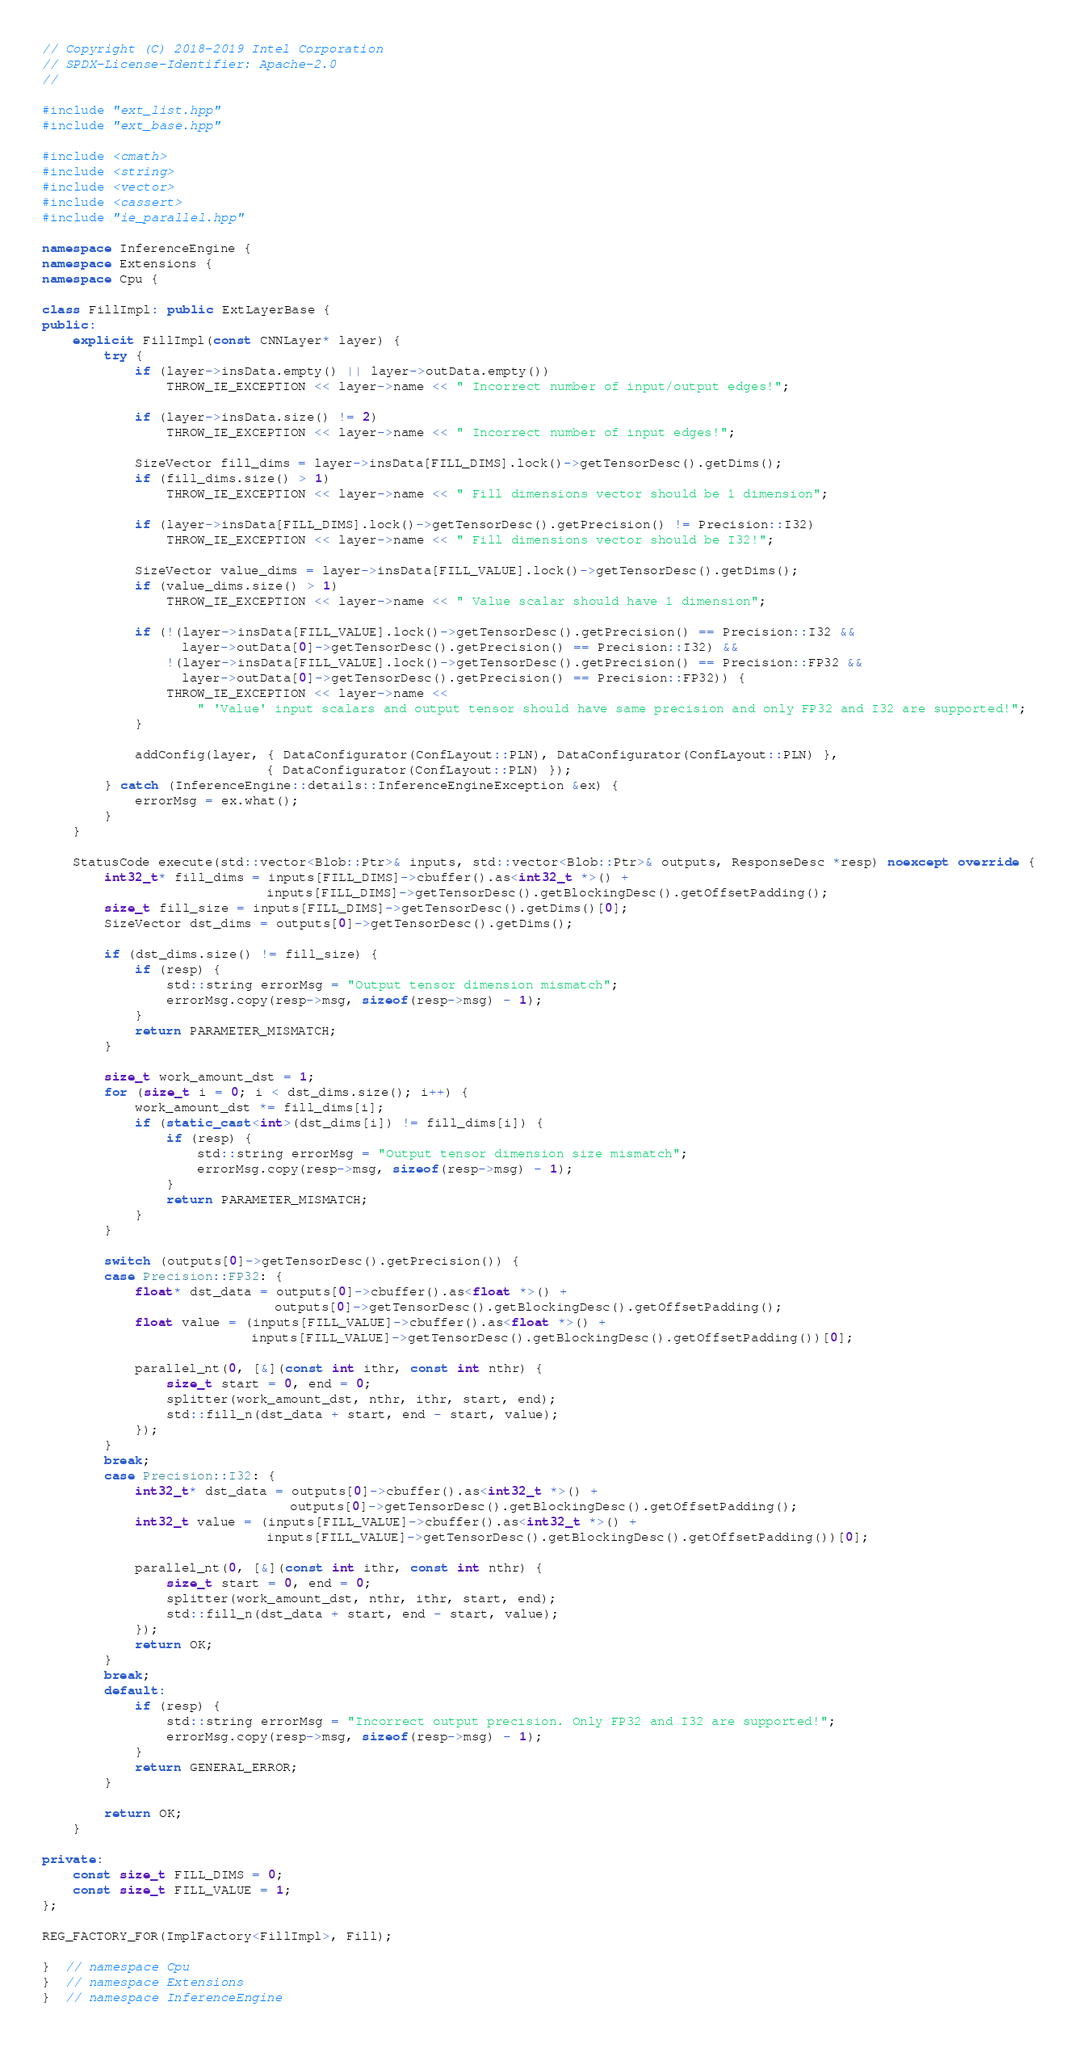Convert code to text. <code><loc_0><loc_0><loc_500><loc_500><_C++_>// Copyright (C) 2018-2019 Intel Corporation
// SPDX-License-Identifier: Apache-2.0
//

#include "ext_list.hpp"
#include "ext_base.hpp"

#include <cmath>
#include <string>
#include <vector>
#include <cassert>
#include "ie_parallel.hpp"

namespace InferenceEngine {
namespace Extensions {
namespace Cpu {

class FillImpl: public ExtLayerBase {
public:
    explicit FillImpl(const CNNLayer* layer) {
        try {
            if (layer->insData.empty() || layer->outData.empty())
                THROW_IE_EXCEPTION << layer->name << " Incorrect number of input/output edges!";

            if (layer->insData.size() != 2)
                THROW_IE_EXCEPTION << layer->name << " Incorrect number of input edges!";

            SizeVector fill_dims = layer->insData[FILL_DIMS].lock()->getTensorDesc().getDims();
            if (fill_dims.size() > 1)
                THROW_IE_EXCEPTION << layer->name << " Fill dimensions vector should be 1 dimension";

            if (layer->insData[FILL_DIMS].lock()->getTensorDesc().getPrecision() != Precision::I32)
                THROW_IE_EXCEPTION << layer->name << " Fill dimensions vector should be I32!";

            SizeVector value_dims = layer->insData[FILL_VALUE].lock()->getTensorDesc().getDims();
            if (value_dims.size() > 1)
                THROW_IE_EXCEPTION << layer->name << " Value scalar should have 1 dimension";

            if (!(layer->insData[FILL_VALUE].lock()->getTensorDesc().getPrecision() == Precision::I32 &&
                  layer->outData[0]->getTensorDesc().getPrecision() == Precision::I32) &&
                !(layer->insData[FILL_VALUE].lock()->getTensorDesc().getPrecision() == Precision::FP32 &&
                  layer->outData[0]->getTensorDesc().getPrecision() == Precision::FP32)) {
                THROW_IE_EXCEPTION << layer->name <<
                    " 'Value' input scalars and output tensor should have same precision and only FP32 and I32 are supported!";
            }

            addConfig(layer, { DataConfigurator(ConfLayout::PLN), DataConfigurator(ConfLayout::PLN) },
                             { DataConfigurator(ConfLayout::PLN) });
        } catch (InferenceEngine::details::InferenceEngineException &ex) {
            errorMsg = ex.what();
        }
    }

    StatusCode execute(std::vector<Blob::Ptr>& inputs, std::vector<Blob::Ptr>& outputs, ResponseDesc *resp) noexcept override {
        int32_t* fill_dims = inputs[FILL_DIMS]->cbuffer().as<int32_t *>() +
                             inputs[FILL_DIMS]->getTensorDesc().getBlockingDesc().getOffsetPadding();
        size_t fill_size = inputs[FILL_DIMS]->getTensorDesc().getDims()[0];
        SizeVector dst_dims = outputs[0]->getTensorDesc().getDims();

        if (dst_dims.size() != fill_size) {
            if (resp) {
                std::string errorMsg = "Output tensor dimension mismatch";
                errorMsg.copy(resp->msg, sizeof(resp->msg) - 1);
            }
            return PARAMETER_MISMATCH;
        }

        size_t work_amount_dst = 1;
        for (size_t i = 0; i < dst_dims.size(); i++) {
            work_amount_dst *= fill_dims[i];
            if (static_cast<int>(dst_dims[i]) != fill_dims[i]) {
                if (resp) {
                    std::string errorMsg = "Output tensor dimension size mismatch";
                    errorMsg.copy(resp->msg, sizeof(resp->msg) - 1);
                }
                return PARAMETER_MISMATCH;
            }
        }

        switch (outputs[0]->getTensorDesc().getPrecision()) {
        case Precision::FP32: {
            float* dst_data = outputs[0]->cbuffer().as<float *>() +
                              outputs[0]->getTensorDesc().getBlockingDesc().getOffsetPadding();
            float value = (inputs[FILL_VALUE]->cbuffer().as<float *>() +
                           inputs[FILL_VALUE]->getTensorDesc().getBlockingDesc().getOffsetPadding())[0];

            parallel_nt(0, [&](const int ithr, const int nthr) {
                size_t start = 0, end = 0;
                splitter(work_amount_dst, nthr, ithr, start, end);
                std::fill_n(dst_data + start, end - start, value);
            });
        }
        break;
        case Precision::I32: {
            int32_t* dst_data = outputs[0]->cbuffer().as<int32_t *>() +
                                outputs[0]->getTensorDesc().getBlockingDesc().getOffsetPadding();
            int32_t value = (inputs[FILL_VALUE]->cbuffer().as<int32_t *>() +
                             inputs[FILL_VALUE]->getTensorDesc().getBlockingDesc().getOffsetPadding())[0];

            parallel_nt(0, [&](const int ithr, const int nthr) {
                size_t start = 0, end = 0;
                splitter(work_amount_dst, nthr, ithr, start, end);
                std::fill_n(dst_data + start, end - start, value);
            });
            return OK;
        }
        break;
        default:
            if (resp) {
                std::string errorMsg = "Incorrect output precision. Only FP32 and I32 are supported!";
                errorMsg.copy(resp->msg, sizeof(resp->msg) - 1);
            }
            return GENERAL_ERROR;
        }

        return OK;
    }

private:
    const size_t FILL_DIMS = 0;
    const size_t FILL_VALUE = 1;
};

REG_FACTORY_FOR(ImplFactory<FillImpl>, Fill);

}  // namespace Cpu
}  // namespace Extensions
}  // namespace InferenceEngine
</code> 